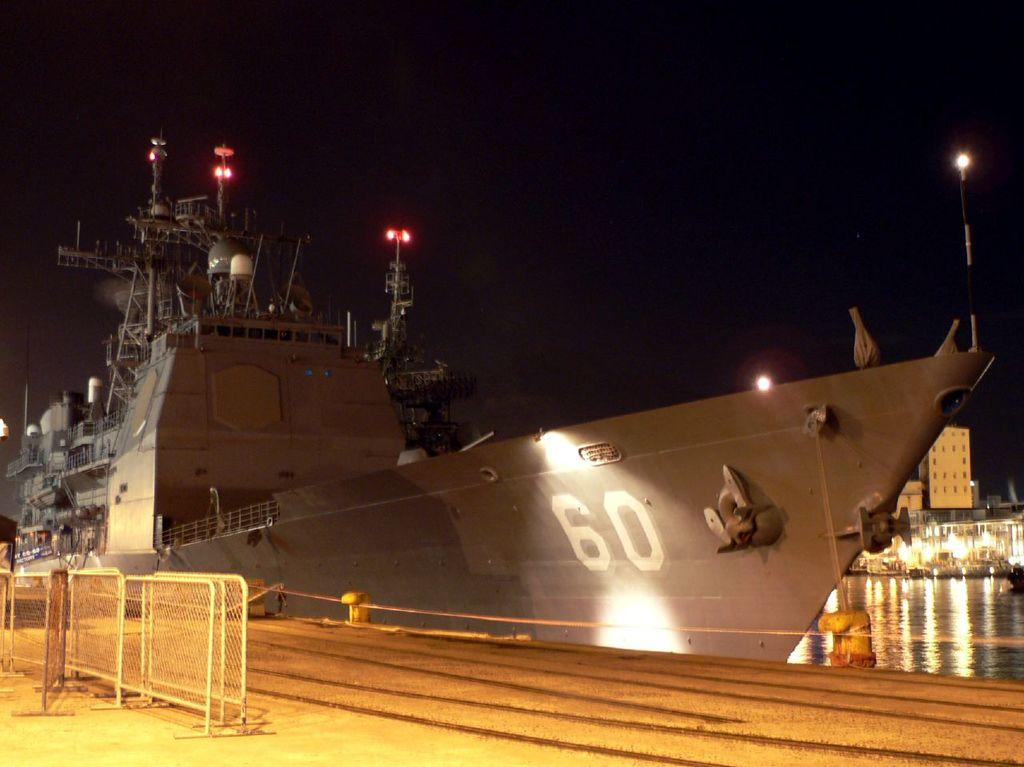<image>
Relay a brief, clear account of the picture shown. A military battleship is docked and has the number 60 on the side. 